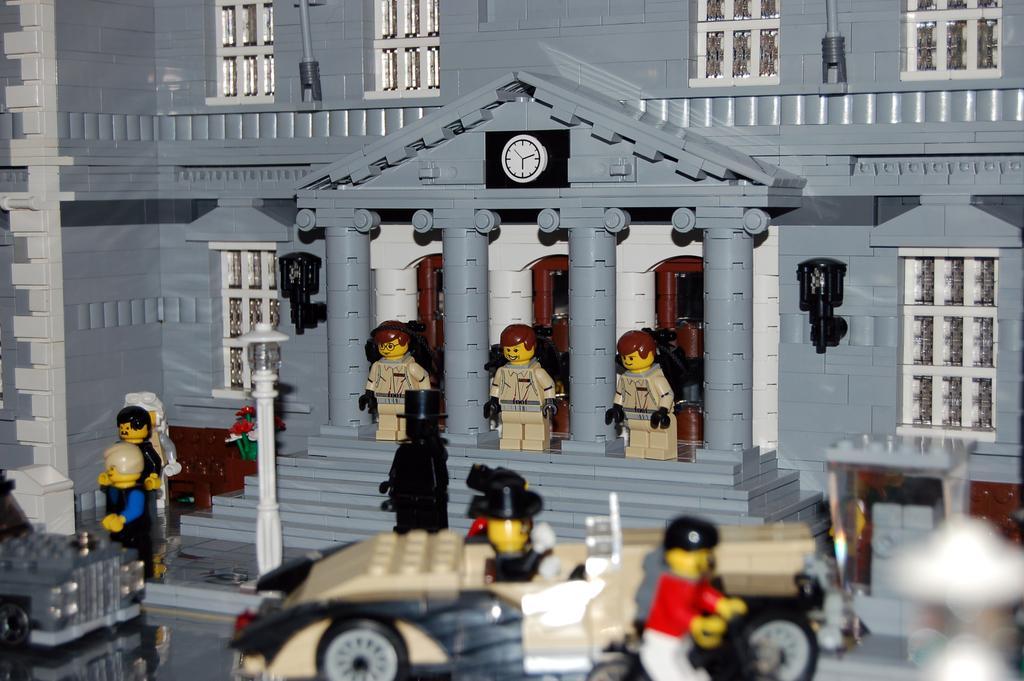Can you describe this image briefly? In this image there is a toy house made with building blocks. At the bottom of the image there are two toy vehicles and in this image there are many toys. 